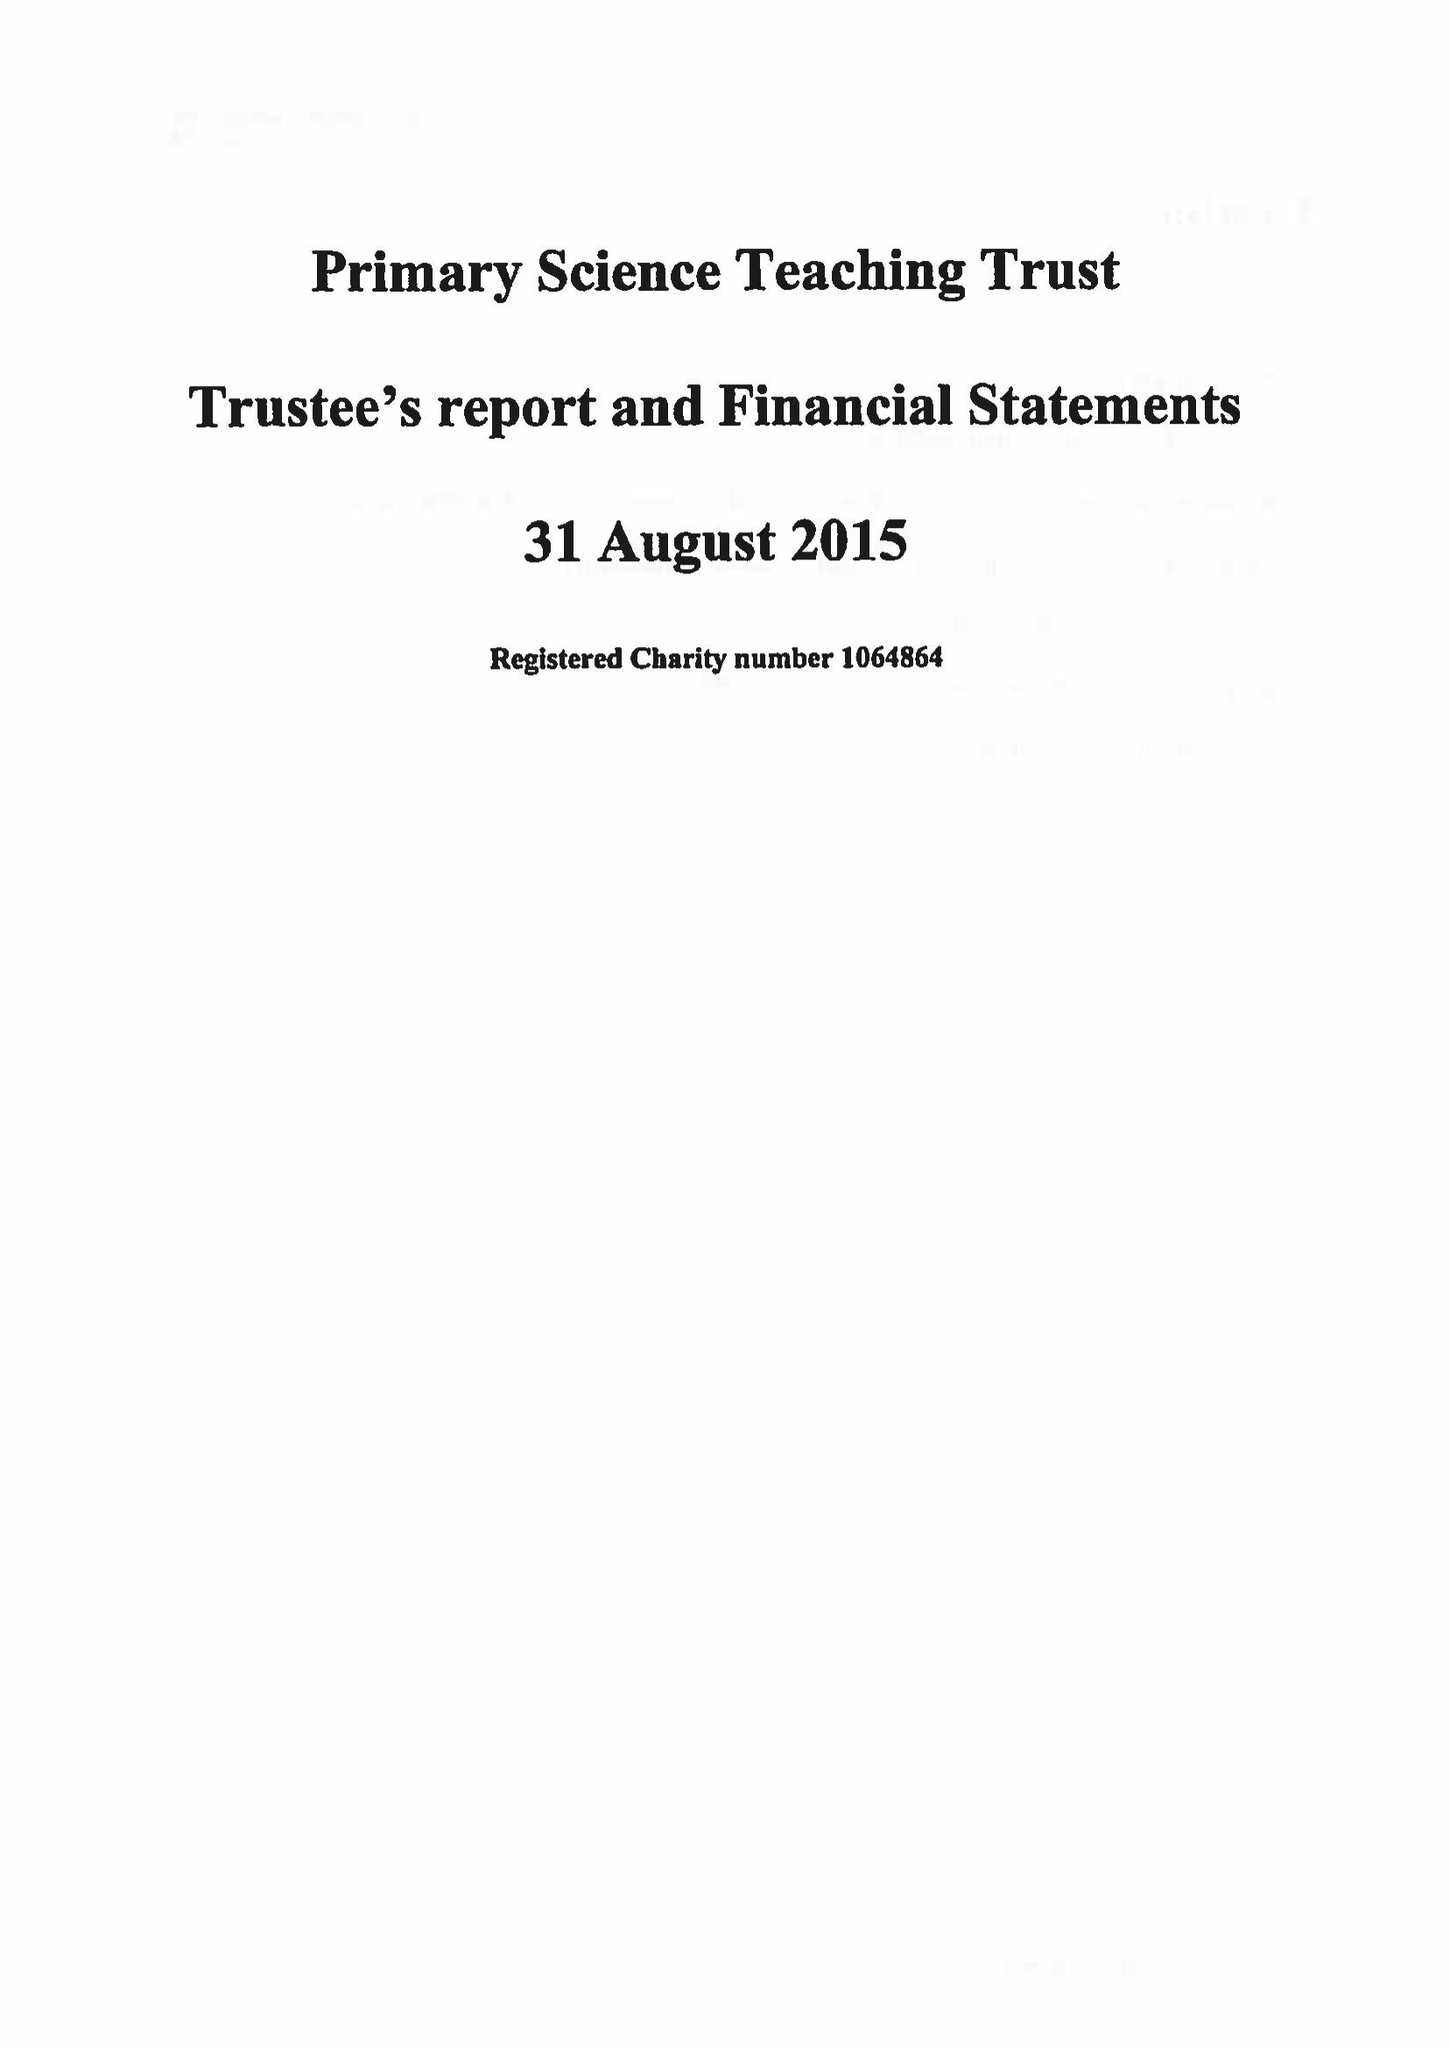What is the value for the address__post_town?
Answer the question using a single word or phrase. BRISTOL 